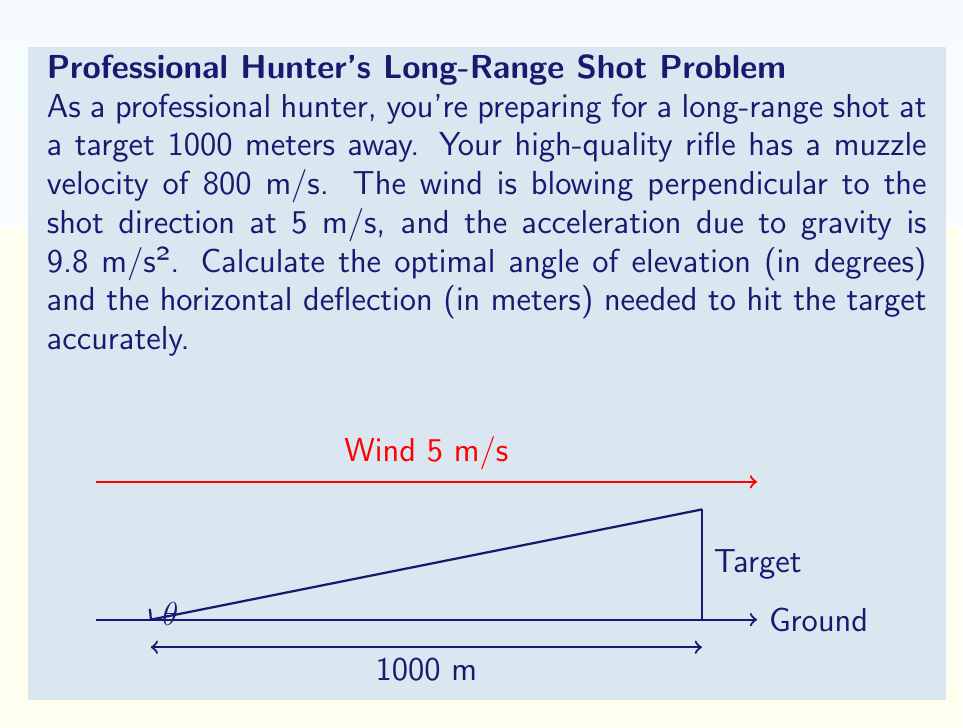Give your solution to this math problem. Let's approach this problem step by step:

1) First, we need to calculate the time of flight. Using the horizontal distance equation:

   $$x = v_0 \cos(\theta) t$$

   Where $x = 1000$ m, $v_0 = 800$ m/s, and $t$ is the time we're solving for.

2) We also know that at the target, the vertical displacement should be zero:

   $$y = v_0 \sin(\theta) t - \frac{1}{2}gt^2 = 0$$

3) From these two equations, we can derive:

   $$\tan(\theta) = \frac{gx}{2v_0^2}$$

4) Substituting our values:

   $$\tan(\theta) = \frac{9.8 \times 1000}{2 \times 800^2} = 0.007656$$

5) Taking the inverse tangent:

   $$\theta = \arctan(0.007656) = 0.4385 \text{ radians} = 25.13 \text{ degrees}$$

6) Now that we have $\theta$, we can calculate $t$:

   $$t = \frac{x}{v_0 \cos(\theta)} = \frac{1000}{800 \cos(0.4385)} = 1.2563 \text{ seconds}$$

7) For the horizontal deflection due to wind, we use:

   $$d = v_w t$$

   Where $v_w$ is the wind velocity (5 m/s).

8) Substituting:

   $$d = 5 \times 1.2563 = 6.2815 \text{ meters}$$

Therefore, the optimal angle of elevation is 25.13 degrees, and the horizontal deflection needed is 6.28 meters.
Answer: $\theta = 25.13°$, deflection = 6.28 m 